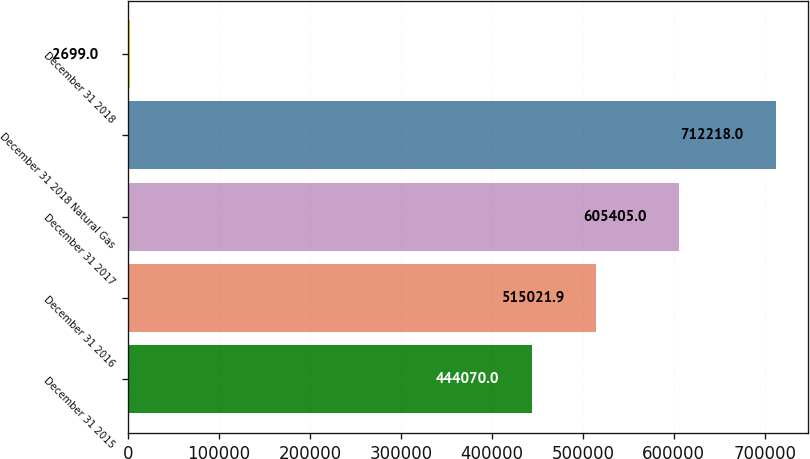<chart> <loc_0><loc_0><loc_500><loc_500><bar_chart><fcel>December 31 2015<fcel>December 31 2016<fcel>December 31 2017<fcel>December 31 2018 Natural Gas<fcel>December 31 2018<nl><fcel>444070<fcel>515022<fcel>605405<fcel>712218<fcel>2699<nl></chart> 